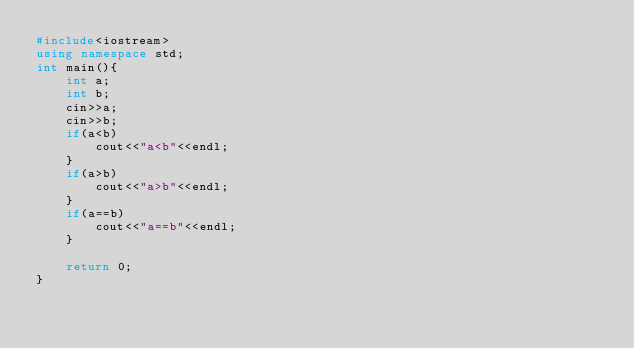Convert code to text. <code><loc_0><loc_0><loc_500><loc_500><_C++_>#include<iostream>
using namespace std;
int main(){
	int a;
	int b;
	cin>>a;
	cin>>b;
	if(a<b)
		cout<<"a<b"<<endl;
	}
	if(a>b)
		cout<<"a>b"<<endl;
	}
	if(a==b)
		cout<<"a==b"<<endl;
	}
	
	return 0;
}
	
	
	
	</code> 